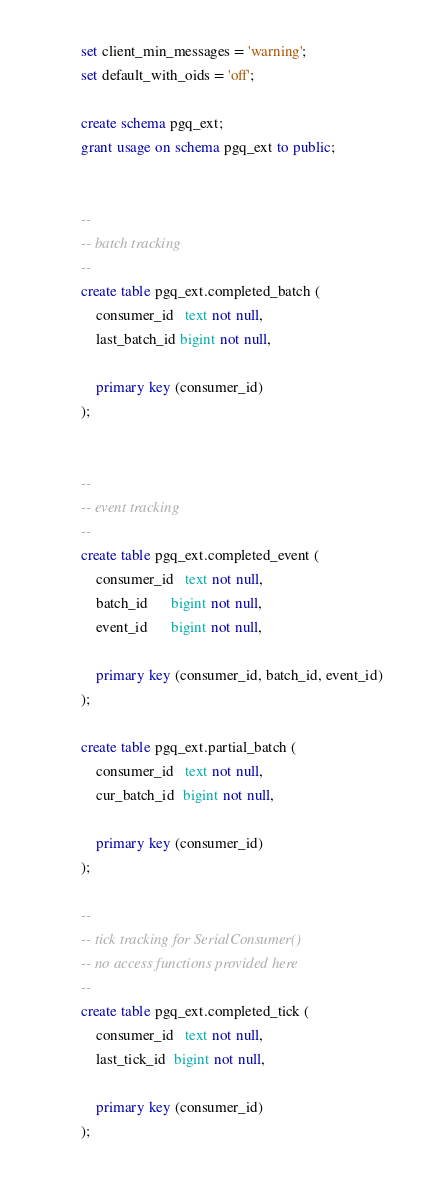<code> <loc_0><loc_0><loc_500><loc_500><_SQL_>
set client_min_messages = 'warning';
set default_with_oids = 'off';

create schema pgq_ext;
grant usage on schema pgq_ext to public;


--
-- batch tracking
--
create table pgq_ext.completed_batch (
    consumer_id   text not null,
    last_batch_id bigint not null,

    primary key (consumer_id)
);


--
-- event tracking
--
create table pgq_ext.completed_event (
    consumer_id   text not null,
    batch_id      bigint not null,
    event_id      bigint not null,

    primary key (consumer_id, batch_id, event_id)
);

create table pgq_ext.partial_batch (
    consumer_id   text not null,
    cur_batch_id  bigint not null,

    primary key (consumer_id)
);

--
-- tick tracking for SerialConsumer()
-- no access functions provided here
--
create table pgq_ext.completed_tick (
    consumer_id   text not null,
    last_tick_id  bigint not null,

    primary key (consumer_id)
);

</code> 